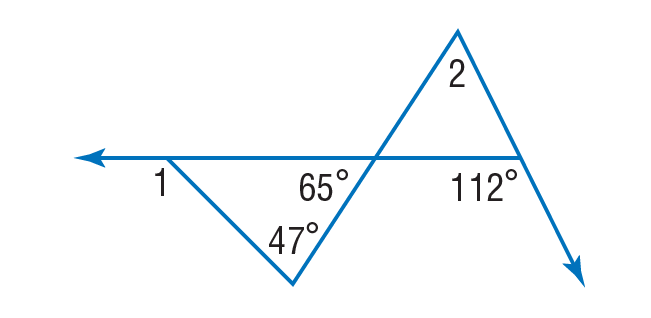Question: Find \angle 1.
Choices:
A. 47
B. 65
C. 112
D. 159
Answer with the letter. Answer: C Question: Find \angle 2.
Choices:
A. 47
B. 65
C. 112
D. 177
Answer with the letter. Answer: A 